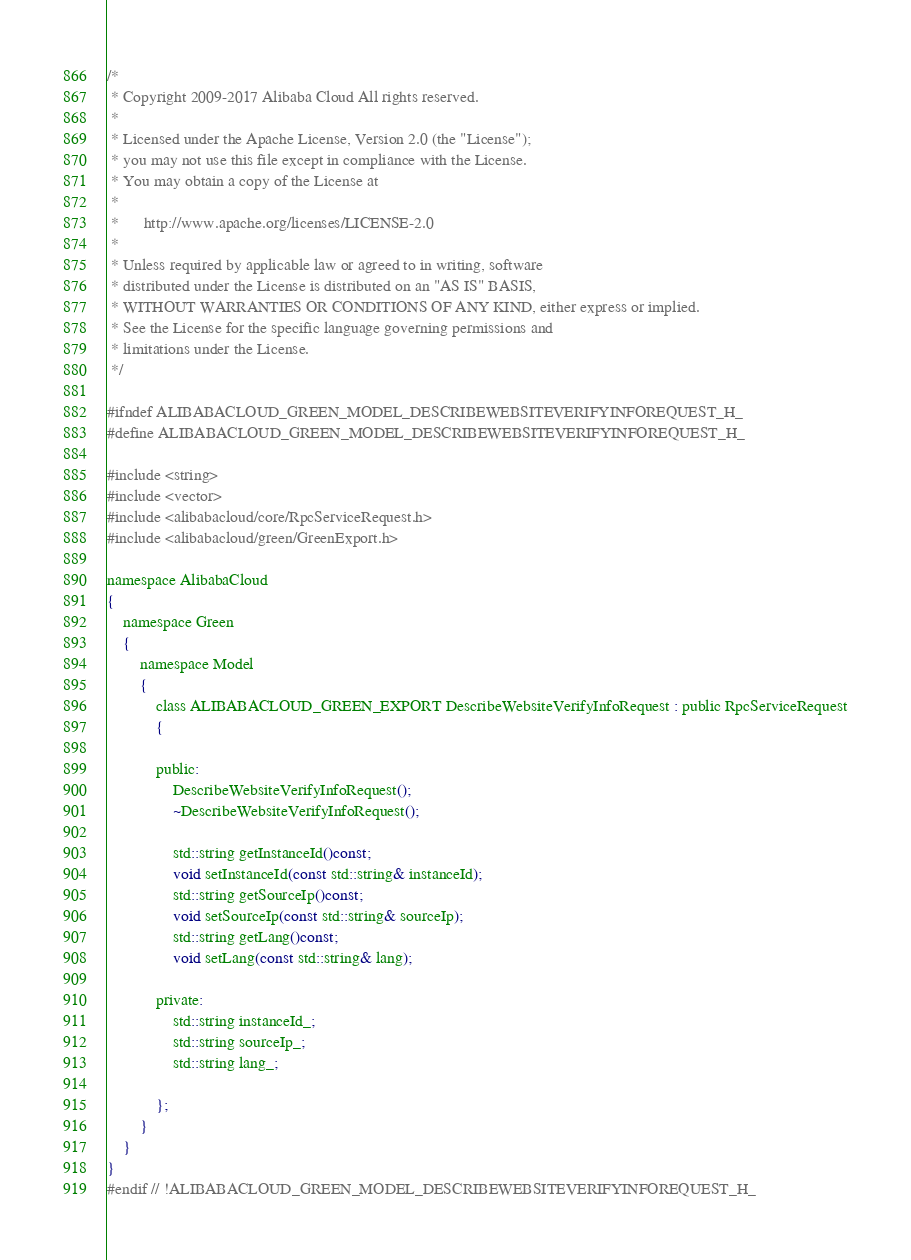Convert code to text. <code><loc_0><loc_0><loc_500><loc_500><_C_>/*
 * Copyright 2009-2017 Alibaba Cloud All rights reserved.
 * 
 * Licensed under the Apache License, Version 2.0 (the "License");
 * you may not use this file except in compliance with the License.
 * You may obtain a copy of the License at
 * 
 *      http://www.apache.org/licenses/LICENSE-2.0
 * 
 * Unless required by applicable law or agreed to in writing, software
 * distributed under the License is distributed on an "AS IS" BASIS,
 * WITHOUT WARRANTIES OR CONDITIONS OF ANY KIND, either express or implied.
 * See the License for the specific language governing permissions and
 * limitations under the License.
 */

#ifndef ALIBABACLOUD_GREEN_MODEL_DESCRIBEWEBSITEVERIFYINFOREQUEST_H_
#define ALIBABACLOUD_GREEN_MODEL_DESCRIBEWEBSITEVERIFYINFOREQUEST_H_

#include <string>
#include <vector>
#include <alibabacloud/core/RpcServiceRequest.h>
#include <alibabacloud/green/GreenExport.h>

namespace AlibabaCloud
{
	namespace Green
	{
		namespace Model
		{
			class ALIBABACLOUD_GREEN_EXPORT DescribeWebsiteVerifyInfoRequest : public RpcServiceRequest
			{

			public:
				DescribeWebsiteVerifyInfoRequest();
				~DescribeWebsiteVerifyInfoRequest();

				std::string getInstanceId()const;
				void setInstanceId(const std::string& instanceId);
				std::string getSourceIp()const;
				void setSourceIp(const std::string& sourceIp);
				std::string getLang()const;
				void setLang(const std::string& lang);

            private:
				std::string instanceId_;
				std::string sourceIp_;
				std::string lang_;

			};
		}
	}
}
#endif // !ALIBABACLOUD_GREEN_MODEL_DESCRIBEWEBSITEVERIFYINFOREQUEST_H_</code> 